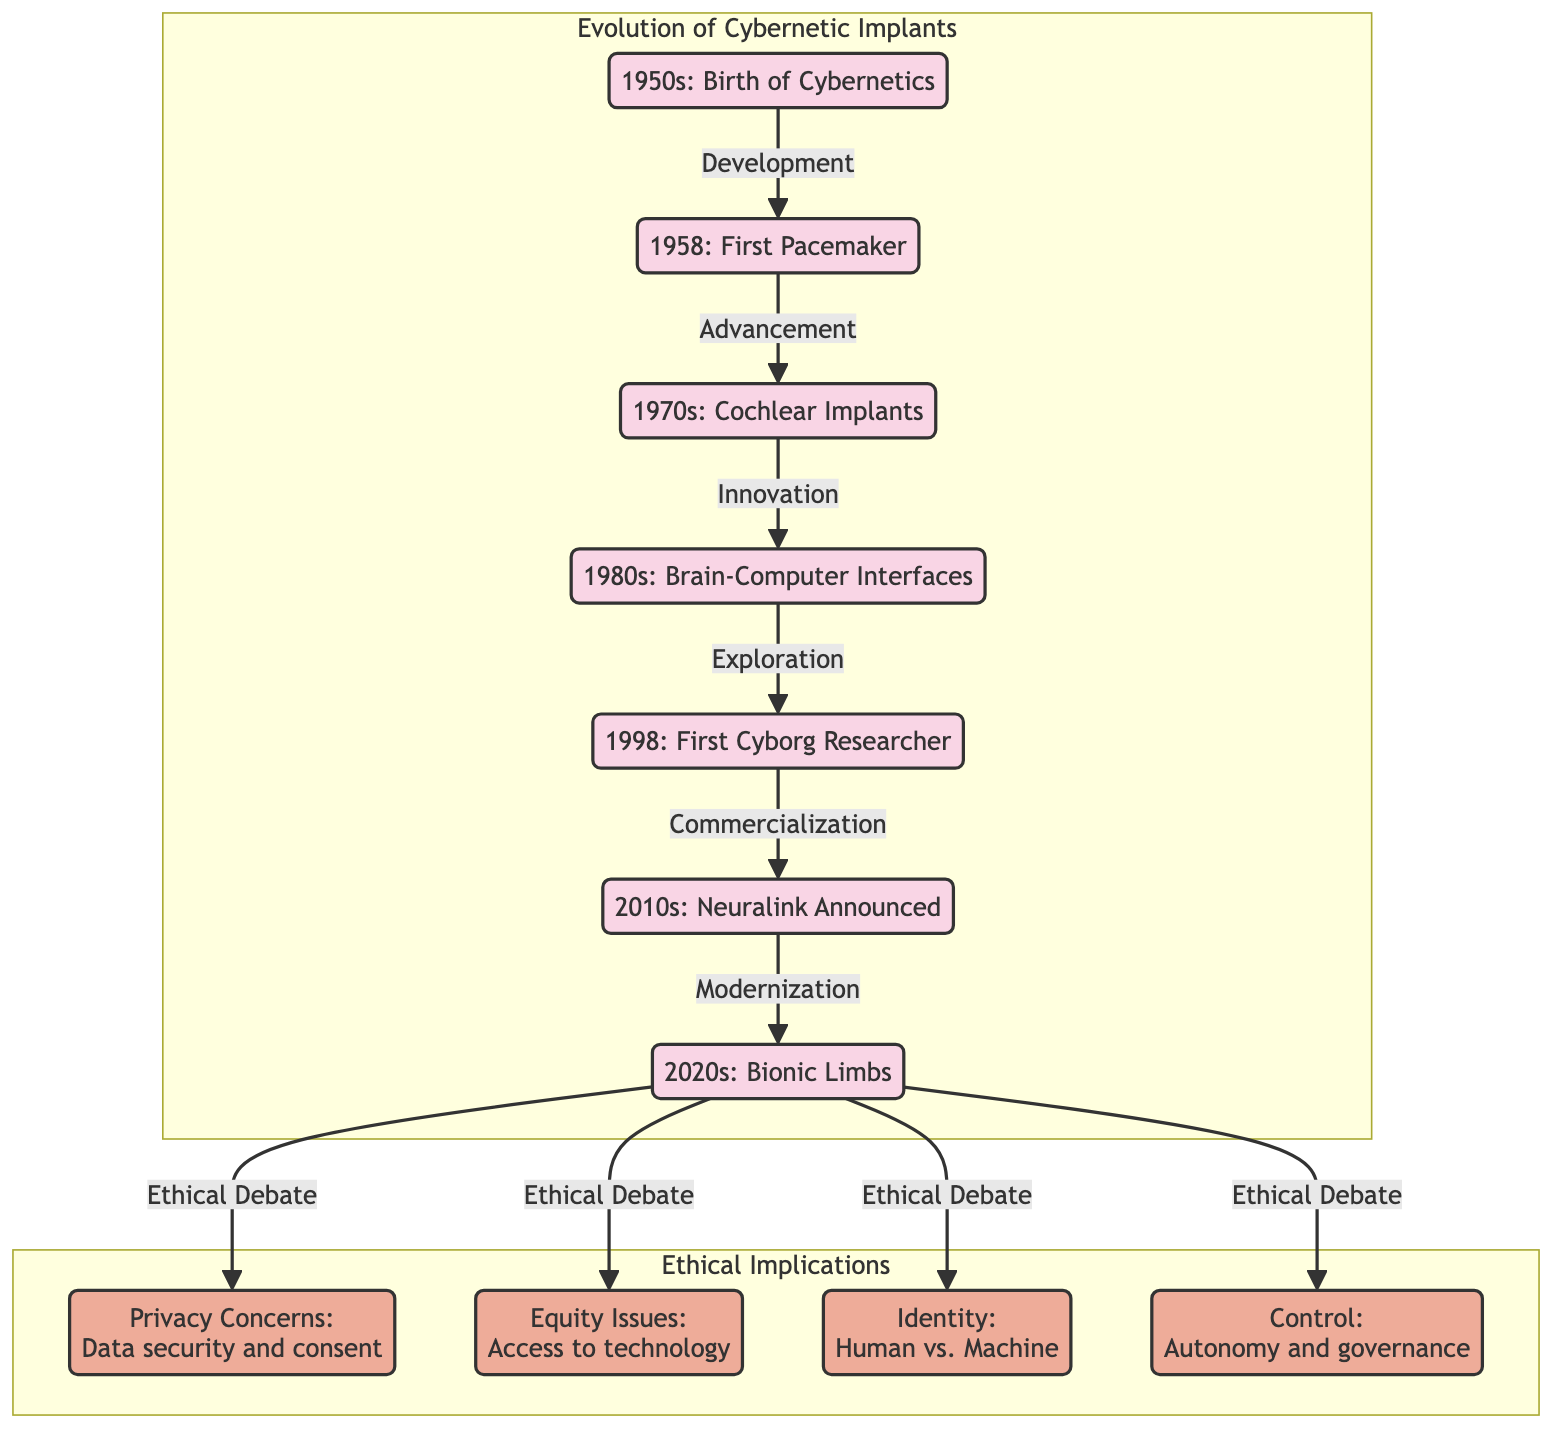What decade marks the birth of cybernetics? The diagram indicates that the birth of cybernetics occurred in the 1950s, as the initial node states "1950s: Birth of Cybernetics."
Answer: 1950s What technological milestone occurred in 1958? According to the diagram, the technological milestone in 1958 was the "First Pacemaker," as mentioned in the corresponding node.
Answer: First Pacemaker How many ethical implications are listed in the diagram? The diagram displays four ethical implications, which are represented as nodes under "Ethical Implications." These are privacy, equity, identity, and control.
Answer: 4 What is the relationship between the 1998 milestone and the 2010s? The diagram shows a directed arrow labeled "Commercialization" from the node of the milestone in 1998, "First Cyborg Researcher," to the 2010s node, indicating a relationship.
Answer: Commercialization What ethical debate is associated with the 2020s? The diagram connects the 2020s to four ethical debates, one of which is privacy, as identified by the arrow pointing to the privacy node.
Answer: Privacy What milestone follows the development from the 1950s? Following the development from the 1950s, the next milestone in the diagram is the first pacemaker in 1958, indicated by an arrow pointing to the respective node.
Answer: First Pacemaker Which ethical concern focuses on technology access? The diagram highlights equity issues as the ethical concern focusing on access to technology, shown as the "Equity Issues" node in the ethical implications section.
Answer: Equity Issues What is the main focus of the 1980s in the timeline? The timeline indicates that the main focus of the 1980s is "Brain-Computer Interfaces," as represented in the corresponding node.
Answer: Brain-Computer Interfaces What is the last node in the timeline? The last node in the timeline is "2020s: Bionic Limbs," which is depicted at the end of the chronological sequence of cybernetic advancements.
Answer: Bionic Limbs Which decade introduced cochlear implants? The diagram points to the 1970s as the decade when cochlear implants were introduced, clearly marked in the respective node.
Answer: 1970s 